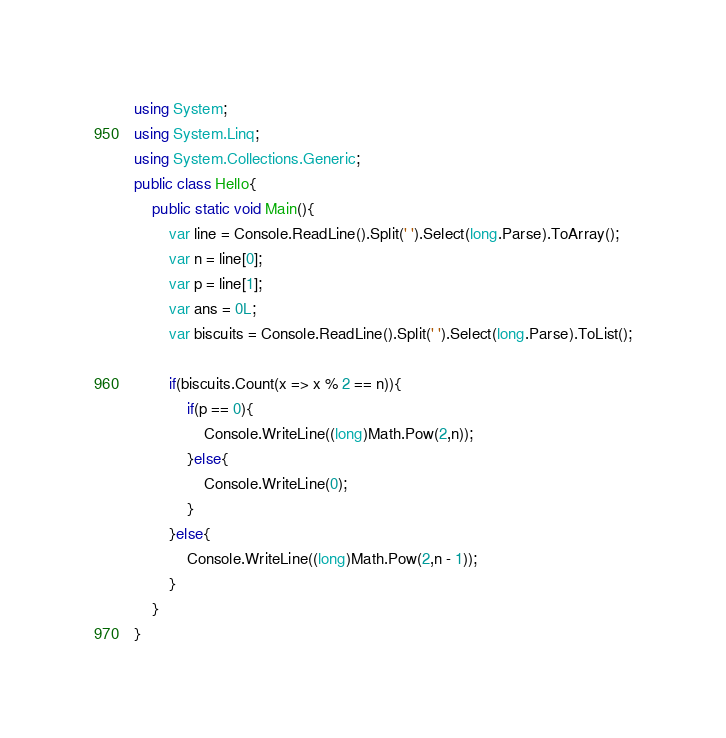<code> <loc_0><loc_0><loc_500><loc_500><_C#_>using System;
using System.Linq;
using System.Collections.Generic;
public class Hello{
    public static void Main(){
        var line = Console.ReadLine().Split(' ').Select(long.Parse).ToArray();
        var n = line[0];
        var p = line[1];
        var ans = 0L;
        var biscuits = Console.ReadLine().Split(' ').Select(long.Parse).ToList();
        
        if(biscuits.Count(x => x % 2 == n)){
            if(p == 0){
                Console.WriteLine((long)Math.Pow(2,n));
            }else{
                Console.WriteLine(0);
            }
        }else{
            Console.WriteLine((long)Math.Pow(2,n - 1));
        }
    }
}
</code> 